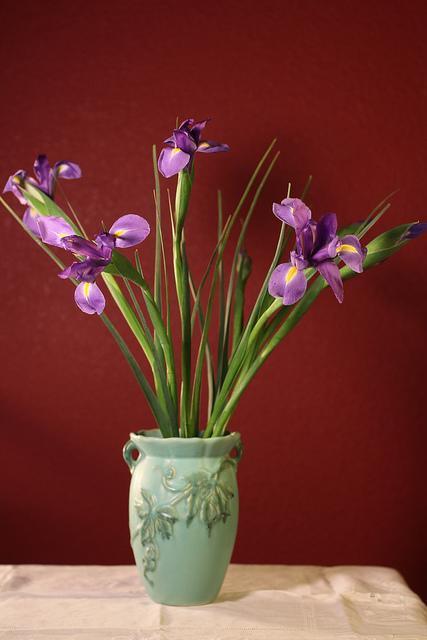How many purple flowers are in there?
Give a very brief answer. 4. 